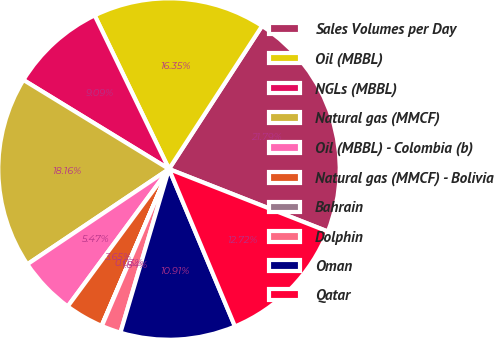Convert chart to OTSL. <chart><loc_0><loc_0><loc_500><loc_500><pie_chart><fcel>Sales Volumes per Day<fcel>Oil (MBBL)<fcel>NGLs (MBBL)<fcel>Natural gas (MMCF)<fcel>Oil (MBBL) - Colombia (b)<fcel>Natural gas (MMCF) - Bolivia<fcel>Bahrain<fcel>Dolphin<fcel>Oman<fcel>Qatar<nl><fcel>21.79%<fcel>16.35%<fcel>9.09%<fcel>18.16%<fcel>5.47%<fcel>3.65%<fcel>0.03%<fcel>1.84%<fcel>10.91%<fcel>12.72%<nl></chart> 